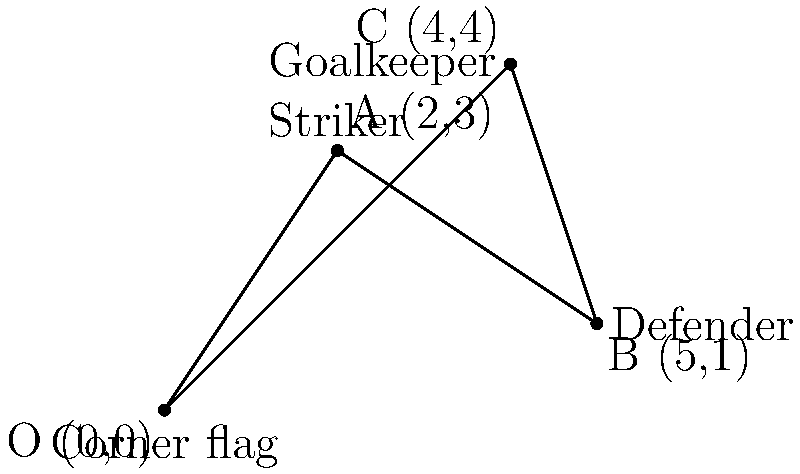During a corner kick in a Cittadella match, the positions of key players are represented by vectors from the corner flag (origin). The striker is at A(2,3), the defender at B(5,1), and the goalkeeper at C(4,4). Calculate the vector from the striker to the goalkeeper using vector subtraction. To find the vector from the striker to the goalkeeper, we need to subtract the striker's position vector from the goalkeeper's position vector. Let's follow these steps:

1. Identify the position vectors:
   Striker (A): $\vec{a} = (2,3)$
   Goalkeeper (C): $\vec{c} = (4,4)$

2. To find the vector from A to C, we use the formula:
   $\vec{AC} = \vec{c} - \vec{a}$

3. Subtract the components:
   $\vec{AC} = (4,4) - (2,3)$
   $\vec{AC} = (4-2, 4-3)$
   $\vec{AC} = (2,1)$

This vector $(2,1)$ represents the displacement from the striker to the goalkeeper.
Answer: $(2,1)$ 